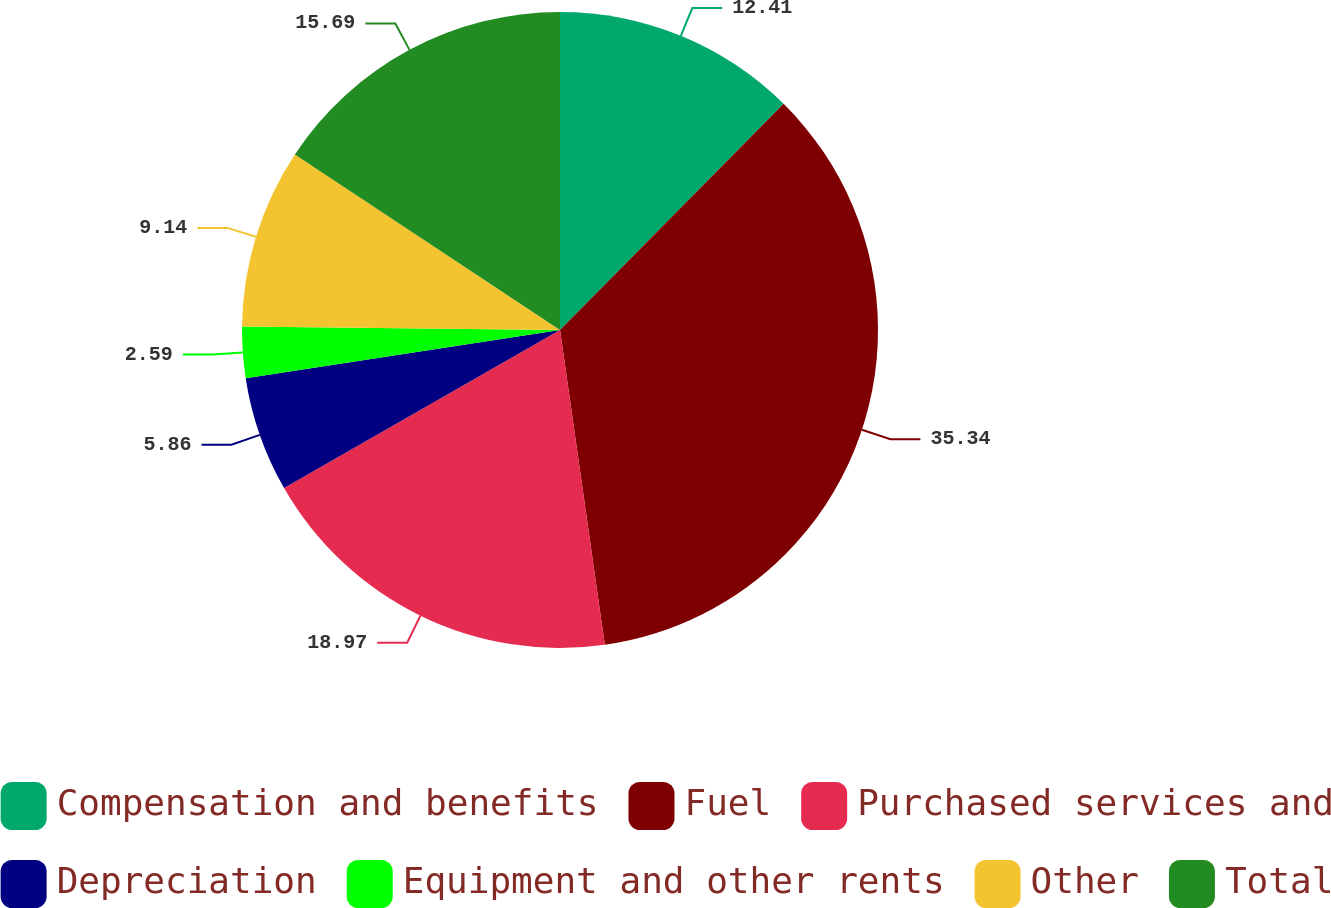Convert chart to OTSL. <chart><loc_0><loc_0><loc_500><loc_500><pie_chart><fcel>Compensation and benefits<fcel>Fuel<fcel>Purchased services and<fcel>Depreciation<fcel>Equipment and other rents<fcel>Other<fcel>Total<nl><fcel>12.41%<fcel>35.34%<fcel>18.97%<fcel>5.86%<fcel>2.59%<fcel>9.14%<fcel>15.69%<nl></chart> 